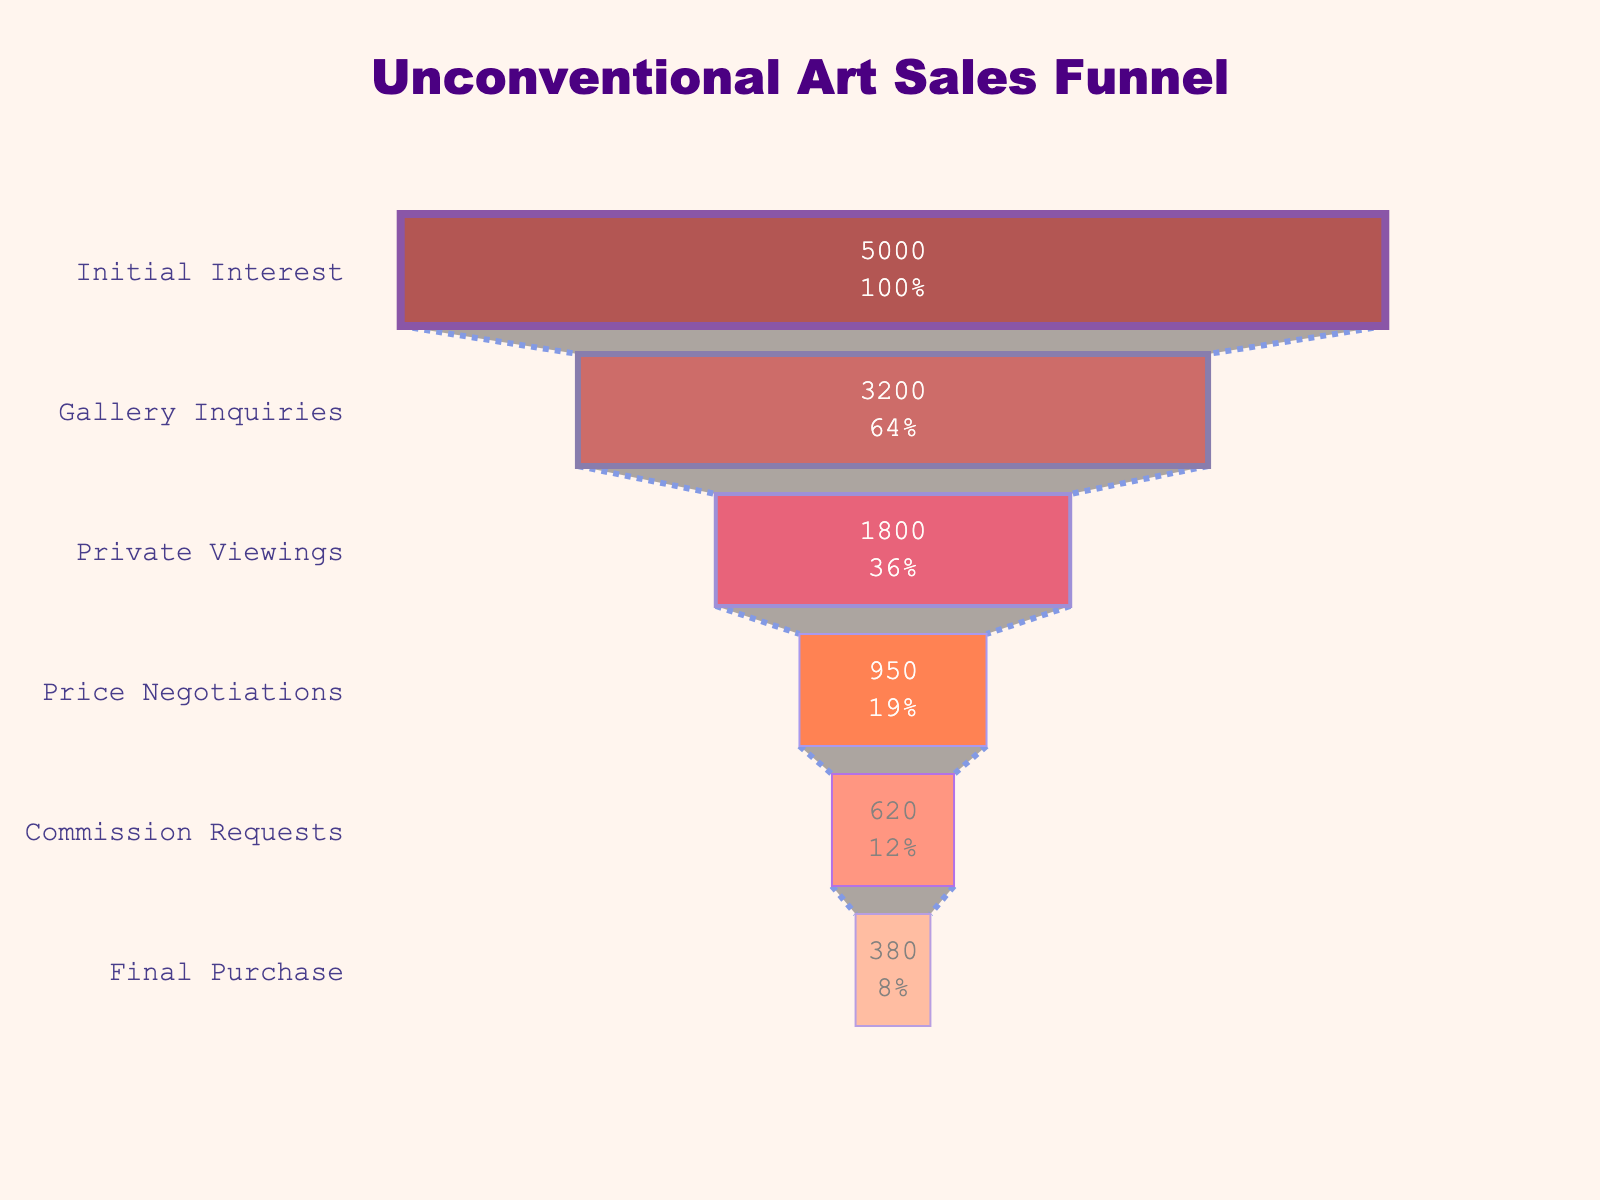What's the title of the chart? The title is displayed at the top of the chart and usually provides a summary of the visualized data. The title of this chart is "Unconventional Art Sales Funnel."
Answer: Unconventional Art Sales Funnel How many sales stages are displayed in the funnel? By counting the distinct stages from top to bottom in the funnel, we can determine the number of sales stages. The chart displays six stages: Initial Interest, Gallery Inquiries, Private Viewings, Price Negotiations, Commission Requests, and Final Purchase.
Answer: Six What color is used for the 'Initial Interest' stage? The color for each stage is visually indicated by the gradient in the funnel chart. The 'Initial Interest' stage at the top uses a deep red color.
Answer: Deep red How many private viewings were there? Referring to the funnel section labeled as 'Private Viewings', the number indicated inside the section is 1800, showing the count of private viewings.
Answer: 1800 Which stage has the highest count? The top of the funnel typically has the highest count, which is also indicated by the value. In this chart, 'Initial Interest' has the highest count of 5000.
Answer: Initial Interest How many fewer commission requests are there compared to gallery inquiries? To find the difference, subtract the number of commission requests from gallery inquiries: 3200 (Gallery Inquiries) - 620 (Commission Requests) = 2580.
Answer: 2580 What percentage of the total initial interest converts to final purchases? To calculate the conversion percentage, divide the number of final purchases by the number of initial interests and multiply by 100: (380 / 5000) * 100 = 7.6%.
Answer: 7.6% Which stage has the largest drop in count compared to the previous stage? Compare the difference between consecutive stages and find the largest drop. The drop from 'Gallery Inquiries' (3200) to 'Private Viewings' (1800) is the largest drop, which is 3200 - 1800 = 1400.
Answer: Gallery Inquiries to Private Viewings What is the cumulative number of customers lost from initial interest to commission requests? Calculate the total number lost by summing the individual differences: (5000 - 3200) + (3200 - 1800) + (1800 - 950) + (950 - 620) = 1800 + 1400 + 850 + 330 = 4380.
Answer: 4380 Which color gradient is used to represent the stages in the funnel chart? The color gradient in the chart is a transition from dark red to light orange, as indicated by the visually represented colors for each stage.
Answer: Dark red to light orange 